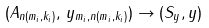Convert formula to latex. <formula><loc_0><loc_0><loc_500><loc_500>( A _ { n ( m _ { i } , k _ { i } ) } , \, y _ { m _ { i } , n ( m _ { i } , k _ { i } ) } ) \to ( S _ { y } , y )</formula> 